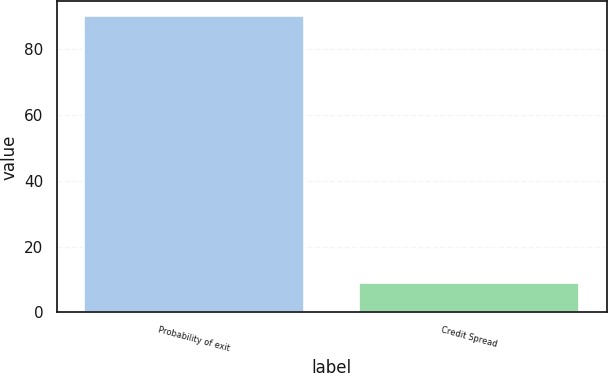<chart> <loc_0><loc_0><loc_500><loc_500><bar_chart><fcel>Probability of exit<fcel>Credit Spread<nl><fcel>90<fcel>8.9<nl></chart> 